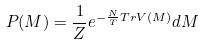<formula> <loc_0><loc_0><loc_500><loc_500>P ( M ) = \frac { 1 } { Z } e ^ { - \frac { N } { T } T r V ( M ) } d M</formula> 